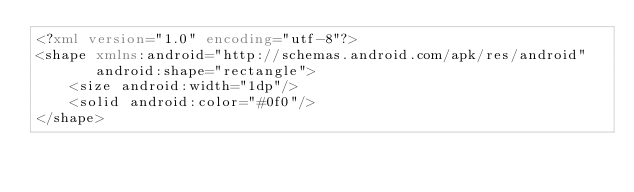<code> <loc_0><loc_0><loc_500><loc_500><_XML_><?xml version="1.0" encoding="utf-8"?>
<shape xmlns:android="http://schemas.android.com/apk/res/android"
       android:shape="rectangle">
    <size android:width="1dp"/>
    <solid android:color="#0f0"/>
</shape></code> 